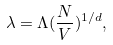Convert formula to latex. <formula><loc_0><loc_0><loc_500><loc_500>\lambda = \Lambda ( \frac { N } { V } ) ^ { 1 / d } ,</formula> 